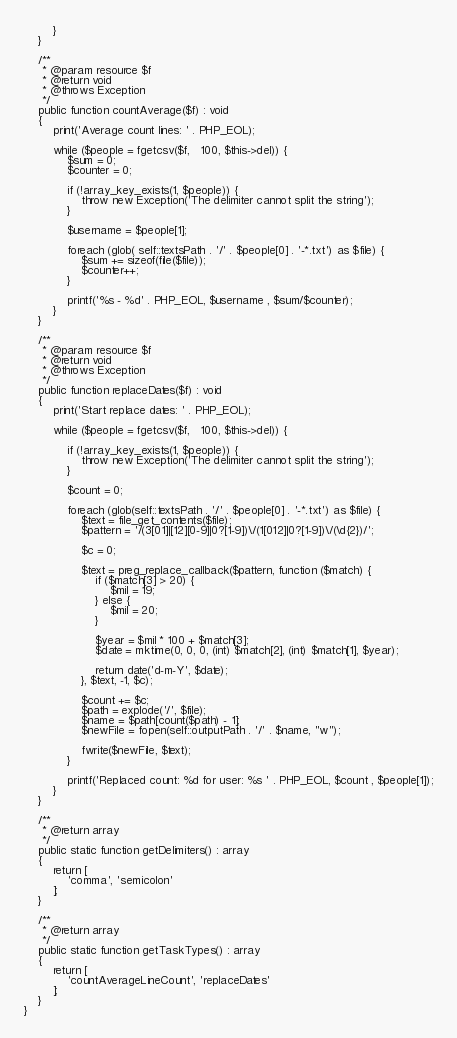<code> <loc_0><loc_0><loc_500><loc_500><_PHP_>        }
    }

    /**
     * @param resource $f
     * @return void
     * @throws Exception
     */
    public function countAverage($f) : void
    {
        print('Average count lines: ' . PHP_EOL);

        while ($people = fgetcsv($f,   100, $this->del)) {
            $sum = 0;
            $counter = 0;

            if (!array_key_exists(1, $people)) {
                throw new Exception('The delimiter cannot split the string');
            }

            $username = $people[1];

            foreach (glob( self::textsPath . '/' . $people[0] . '-*.txt') as $file) {
                $sum += sizeof(file($file));
                $counter++;
            }

            printf('%s - %d' . PHP_EOL, $username , $sum/$counter);
        }
    }

    /**
     * @param resource $f
     * @return void
     * @throws Exception
     */
    public function replaceDates($f) : void
    {
        print('Start replace dates: ' . PHP_EOL);

        while ($people = fgetcsv($f,   100, $this->del)) {

            if (!array_key_exists(1, $people)) {
                throw new Exception('The delimiter cannot split the string');
            }

            $count = 0;

            foreach (glob(self::textsPath . '/' . $people[0] . '-*.txt') as $file) {
                $text = file_get_contents($file);
                $pattern = '/(3[01]|[12][0-9]|0?[1-9])\/(1[012]|0?[1-9])\/(\d{2})/';

                $c = 0;

                $text = preg_replace_callback($pattern, function ($match) {
                    if ($match[3] > 20) {
                        $mil = 19;
                    } else {
                        $mil = 20;
                    }

                    $year = $mil * 100 + $match[3];
                    $date = mktime(0, 0, 0, (int) $match[2], (int) $match[1], $year);

                    return date('d-m-Y', $date);
                }, $text, -1, $c);

                $count += $c;
                $path = explode('/', $file);
                $name = $path[count($path) - 1];
                $newFile = fopen(self::outputPath . '/' . $name, "w");

                fwrite($newFile, $text);
            }

            printf('Replaced count: %d for user: %s ' . PHP_EOL, $count , $people[1]);
        }
    }

    /**
     * @return array
     */
    public static function getDelimiters() : array
    {
        return [
            'comma', 'semicolon'
        ];
    }

    /**
     * @return array
     */
    public static function getTaskTypes() : array
    {
        return [
            'countAverageLineCount', 'replaceDates'
        ];
    }
}</code> 